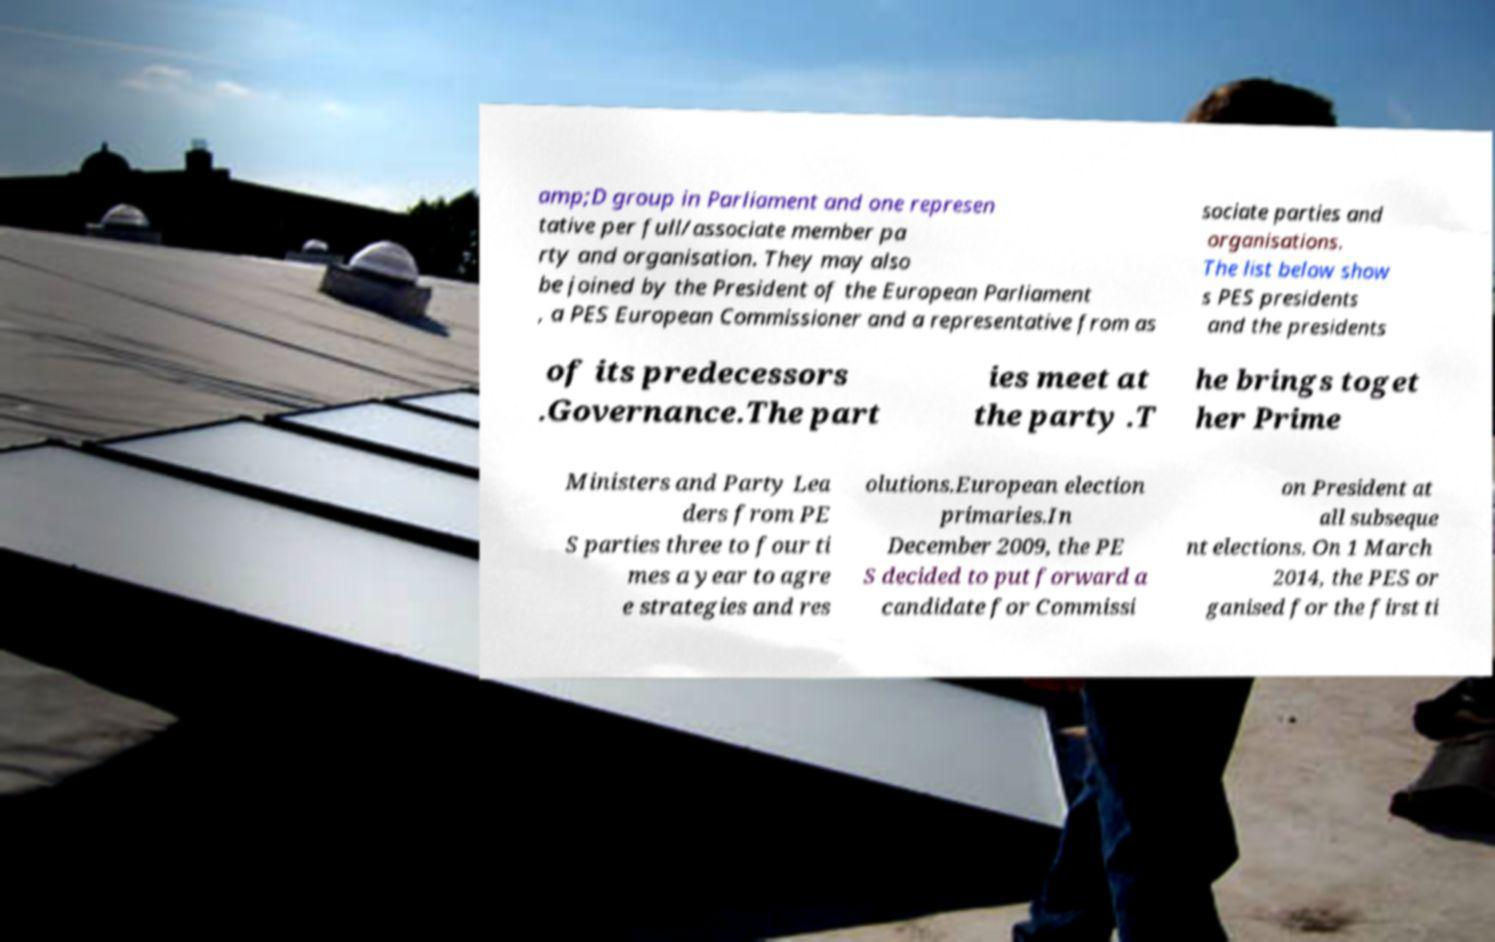Could you extract and type out the text from this image? amp;D group in Parliament and one represen tative per full/associate member pa rty and organisation. They may also be joined by the President of the European Parliament , a PES European Commissioner and a representative from as sociate parties and organisations. The list below show s PES presidents and the presidents of its predecessors .Governance.The part ies meet at the party .T he brings toget her Prime Ministers and Party Lea ders from PE S parties three to four ti mes a year to agre e strategies and res olutions.European election primaries.In December 2009, the PE S decided to put forward a candidate for Commissi on President at all subseque nt elections. On 1 March 2014, the PES or ganised for the first ti 